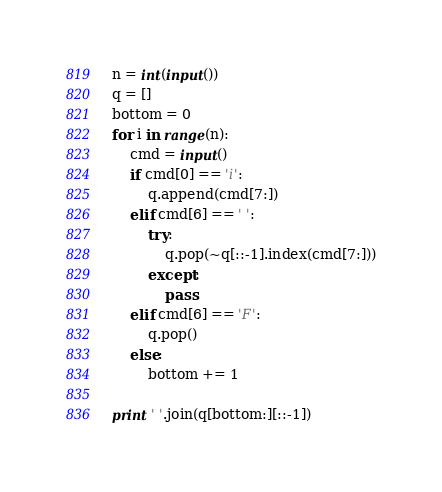Convert code to text. <code><loc_0><loc_0><loc_500><loc_500><_Python_>n = int(input())
q = []
bottom = 0
for i in range(n):
    cmd = input()
    if cmd[0] == 'i':
        q.append(cmd[7:])
    elif cmd[6] == ' ':
        try:
            q.pop(~q[::-1].index(cmd[7:]))
        except:
            pass
    elif cmd[6] == 'F':
        q.pop()
    else:
        bottom += 1
 
print ' '.join(q[bottom:][::-1])</code> 